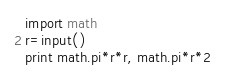Convert code to text. <code><loc_0><loc_0><loc_500><loc_500><_Python_>import math 
r=input()
print math.pi*r*r, math.pi*r*2</code> 